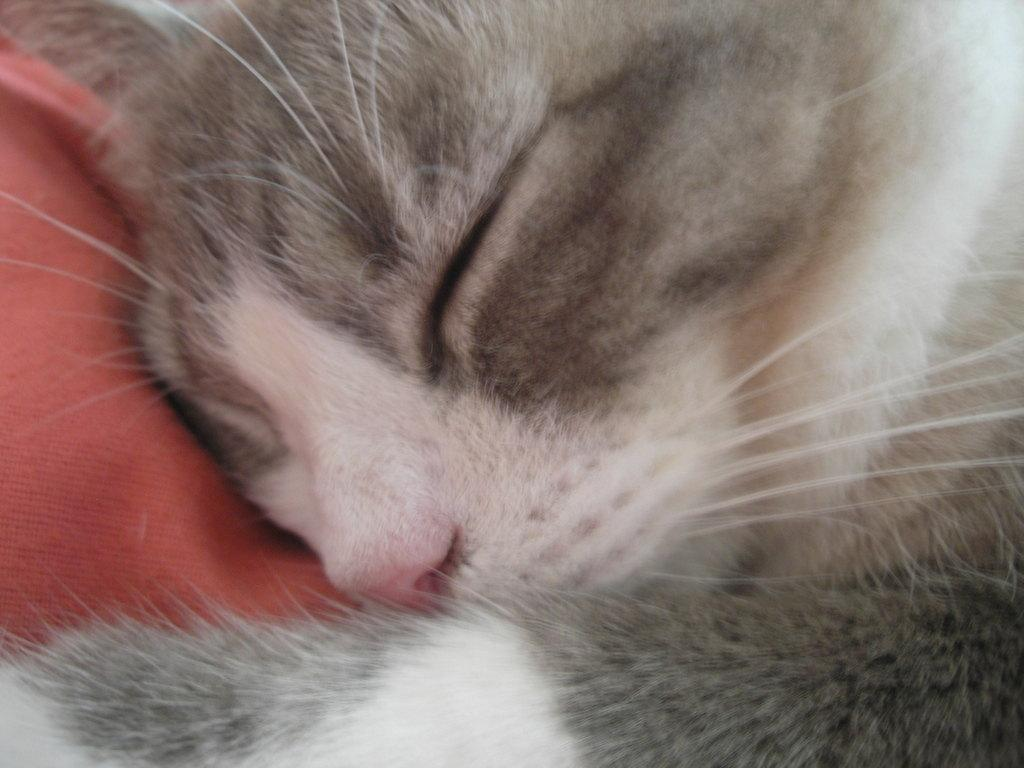What animal can be seen in the image? There is a cat in the image. What is the cat doing in the image? The cat is sleeping. On what surface is the cat resting? The cat is on a cloth. What type of committee is meeting in the image? There is no committee present in the image; it features a sleeping cat on a cloth. What is the cat doing in the tub in the image? There is no tub present in the image, and the cat is not interacting with any water. 